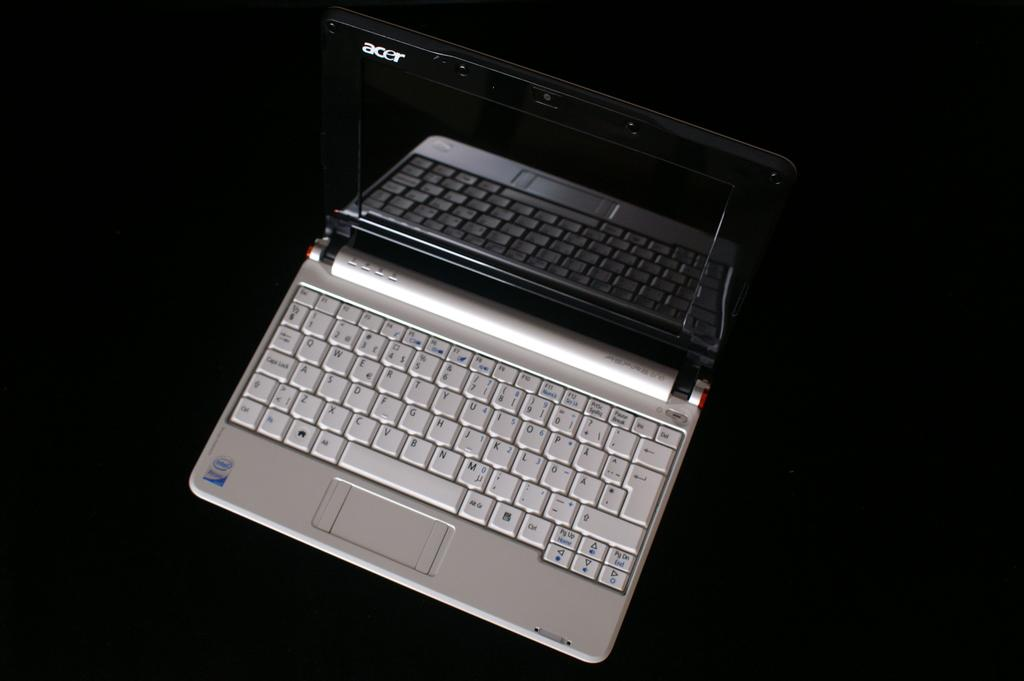Provide a one-sentence caption for the provided image. A black and silver laptop with acer written in the upper left hand corner. 